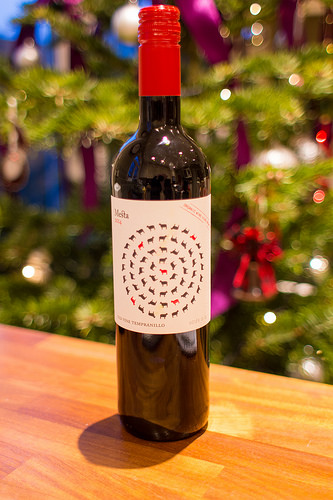<image>
Can you confirm if the wine is to the left of the table? No. The wine is not to the left of the table. From this viewpoint, they have a different horizontal relationship. 